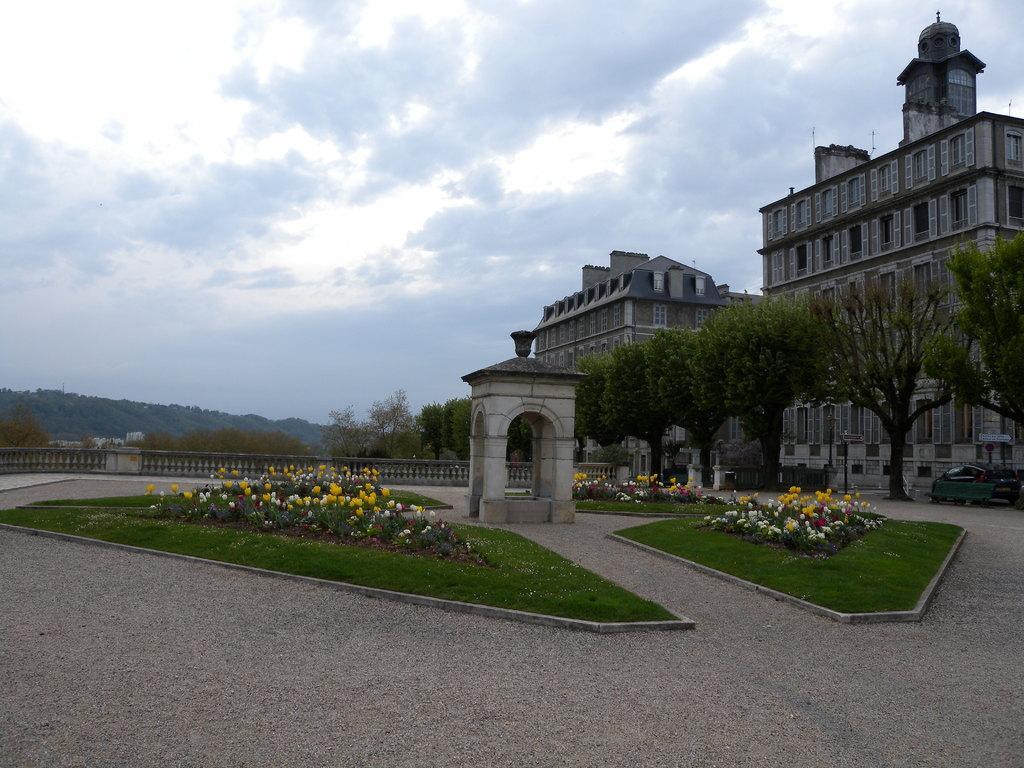In one or two sentences, can you explain what this image depicts? In this picture we can see there are plants with flowers on the grass path and on the right side of the pants there are trees, a vehicle on the path and buildings. Behind the plants there is an architecture, fence, hills and a sky. 